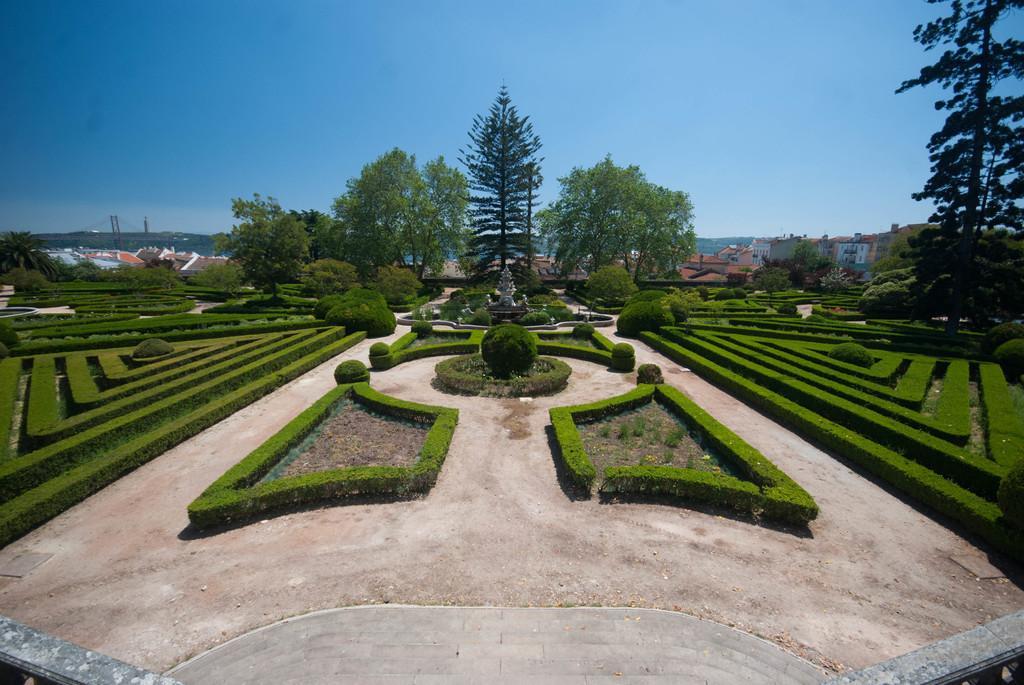Could you give a brief overview of what you see in this image? This picture consists of garden , in the garden I can see bushes and trees and back side of the garden I can see houses and at the top I can see the sky. 